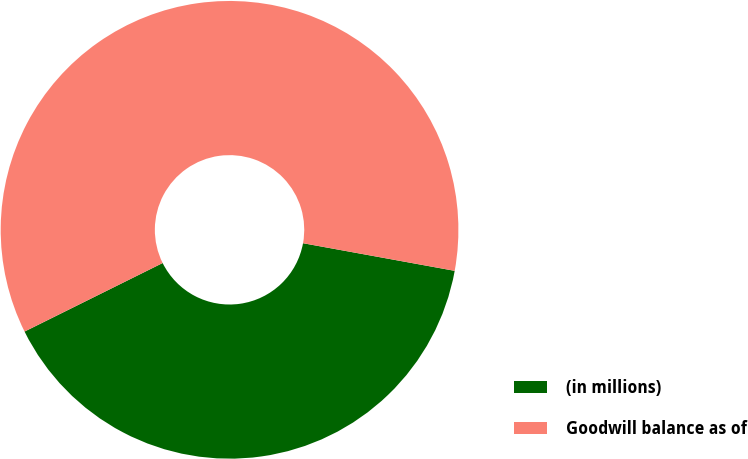Convert chart to OTSL. <chart><loc_0><loc_0><loc_500><loc_500><pie_chart><fcel>(in millions)<fcel>Goodwill balance as of<nl><fcel>39.8%<fcel>60.2%<nl></chart> 